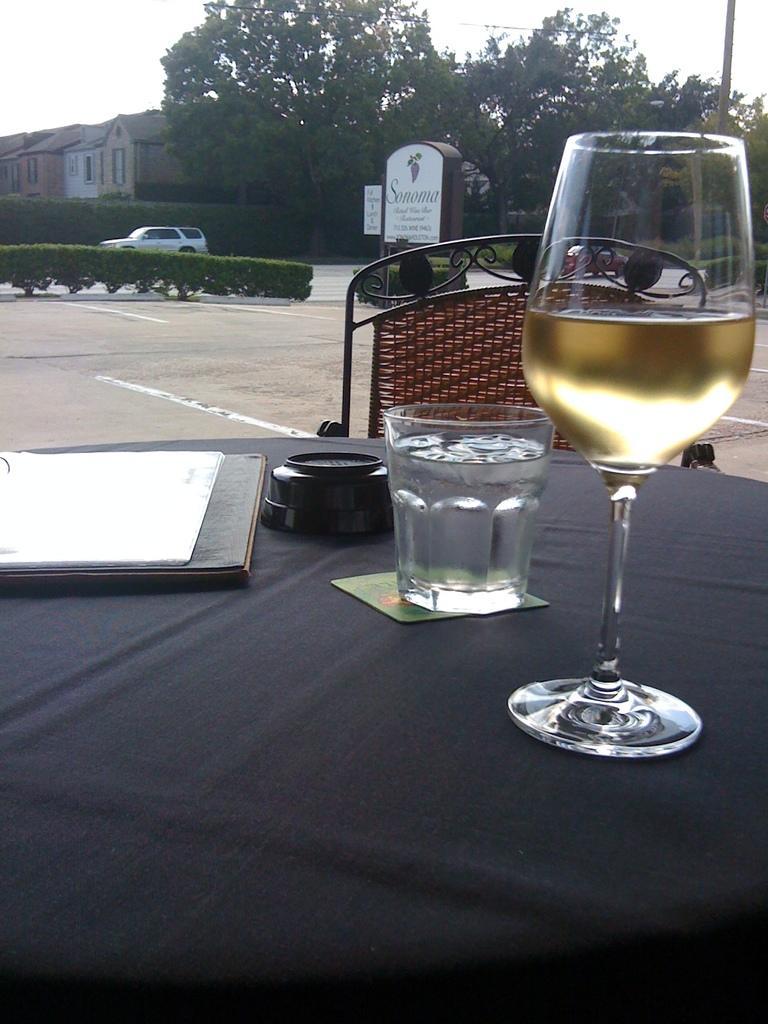Can you describe this image briefly? This picture shows a wine glass and a glass on the table and we see a chair and few houses and couple of trees and a car moving on the road. 